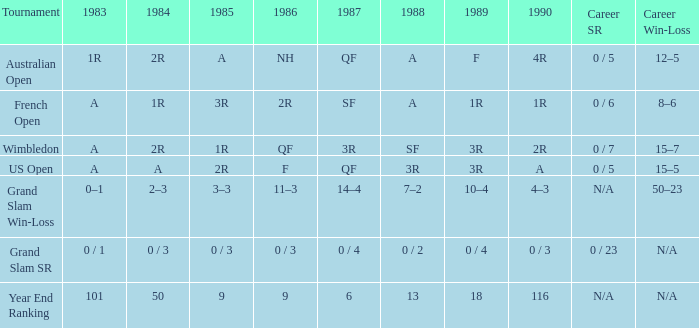With a 1986 of NH and a career SR of 0 / 5 what is the results in 1985? A. 